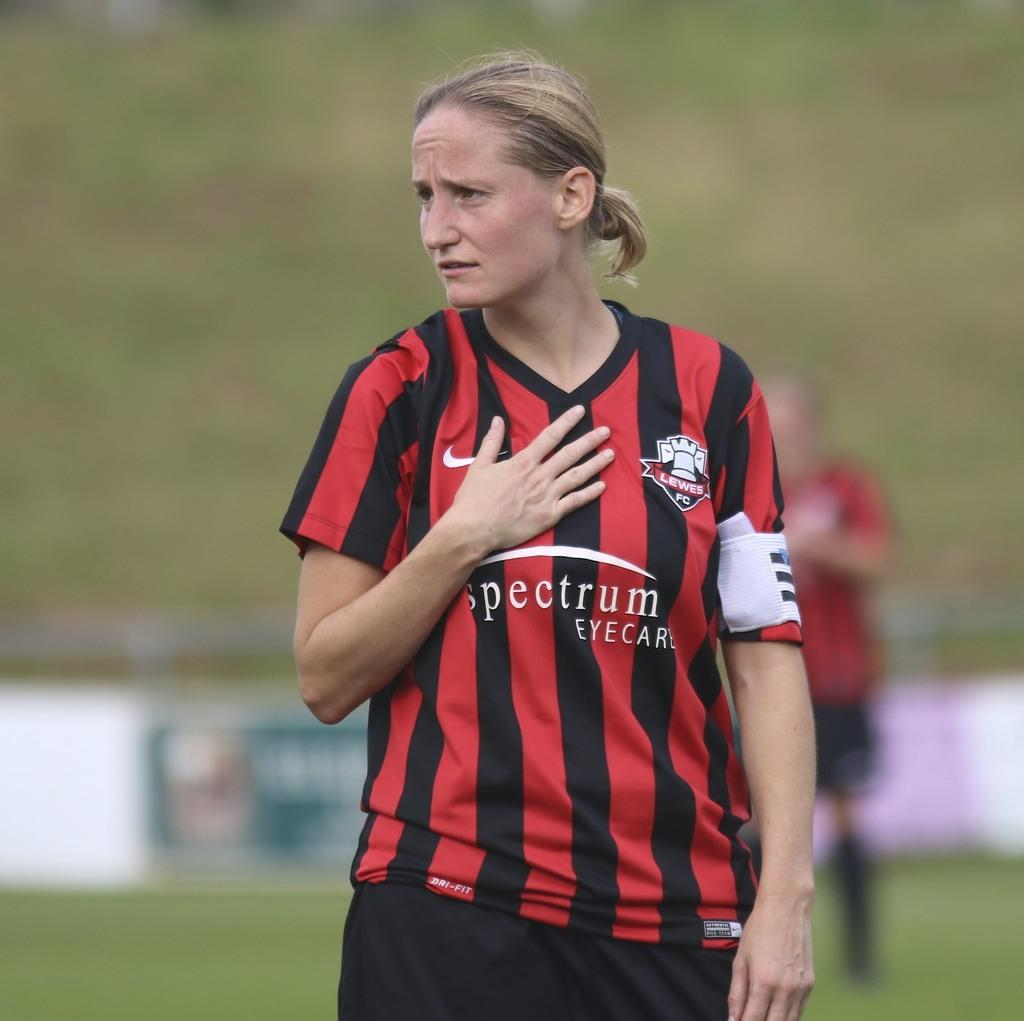<image>
Relay a brief, clear account of the picture shown. A woman in a red and black striped Lewes FC jersey puts her hand over her heart 